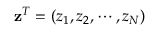Convert formula to latex. <formula><loc_0><loc_0><loc_500><loc_500>z ^ { T } = ( z _ { 1 } , z _ { 2 } , \cdots , z _ { N } )</formula> 